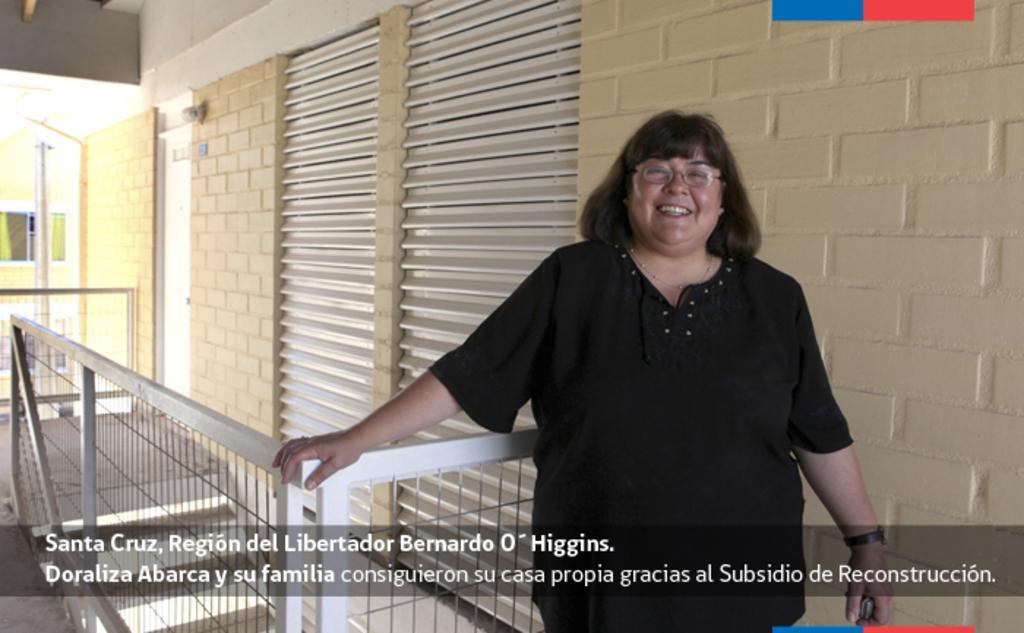How would you summarize this image in a sentence or two? In the picture we can see a woman standing near the railing, behind it we can see a wall with shutters and door. 